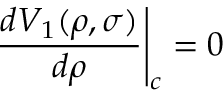Convert formula to latex. <formula><loc_0><loc_0><loc_500><loc_500>\frac { d V _ { 1 } ( \rho , \sigma ) } { d \rho } \right | _ { c } = 0</formula> 